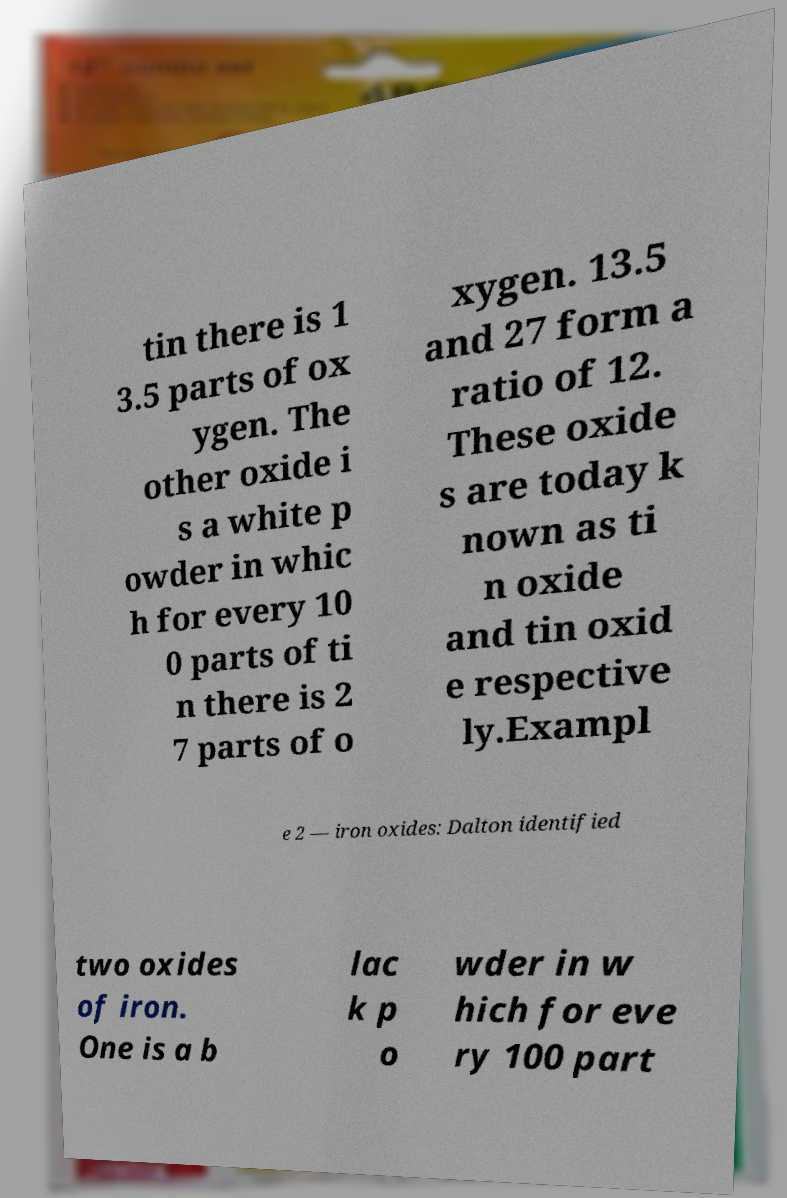Can you read and provide the text displayed in the image?This photo seems to have some interesting text. Can you extract and type it out for me? tin there is 1 3.5 parts of ox ygen. The other oxide i s a white p owder in whic h for every 10 0 parts of ti n there is 2 7 parts of o xygen. 13.5 and 27 form a ratio of 12. These oxide s are today k nown as ti n oxide and tin oxid e respective ly.Exampl e 2 — iron oxides: Dalton identified two oxides of iron. One is a b lac k p o wder in w hich for eve ry 100 part 